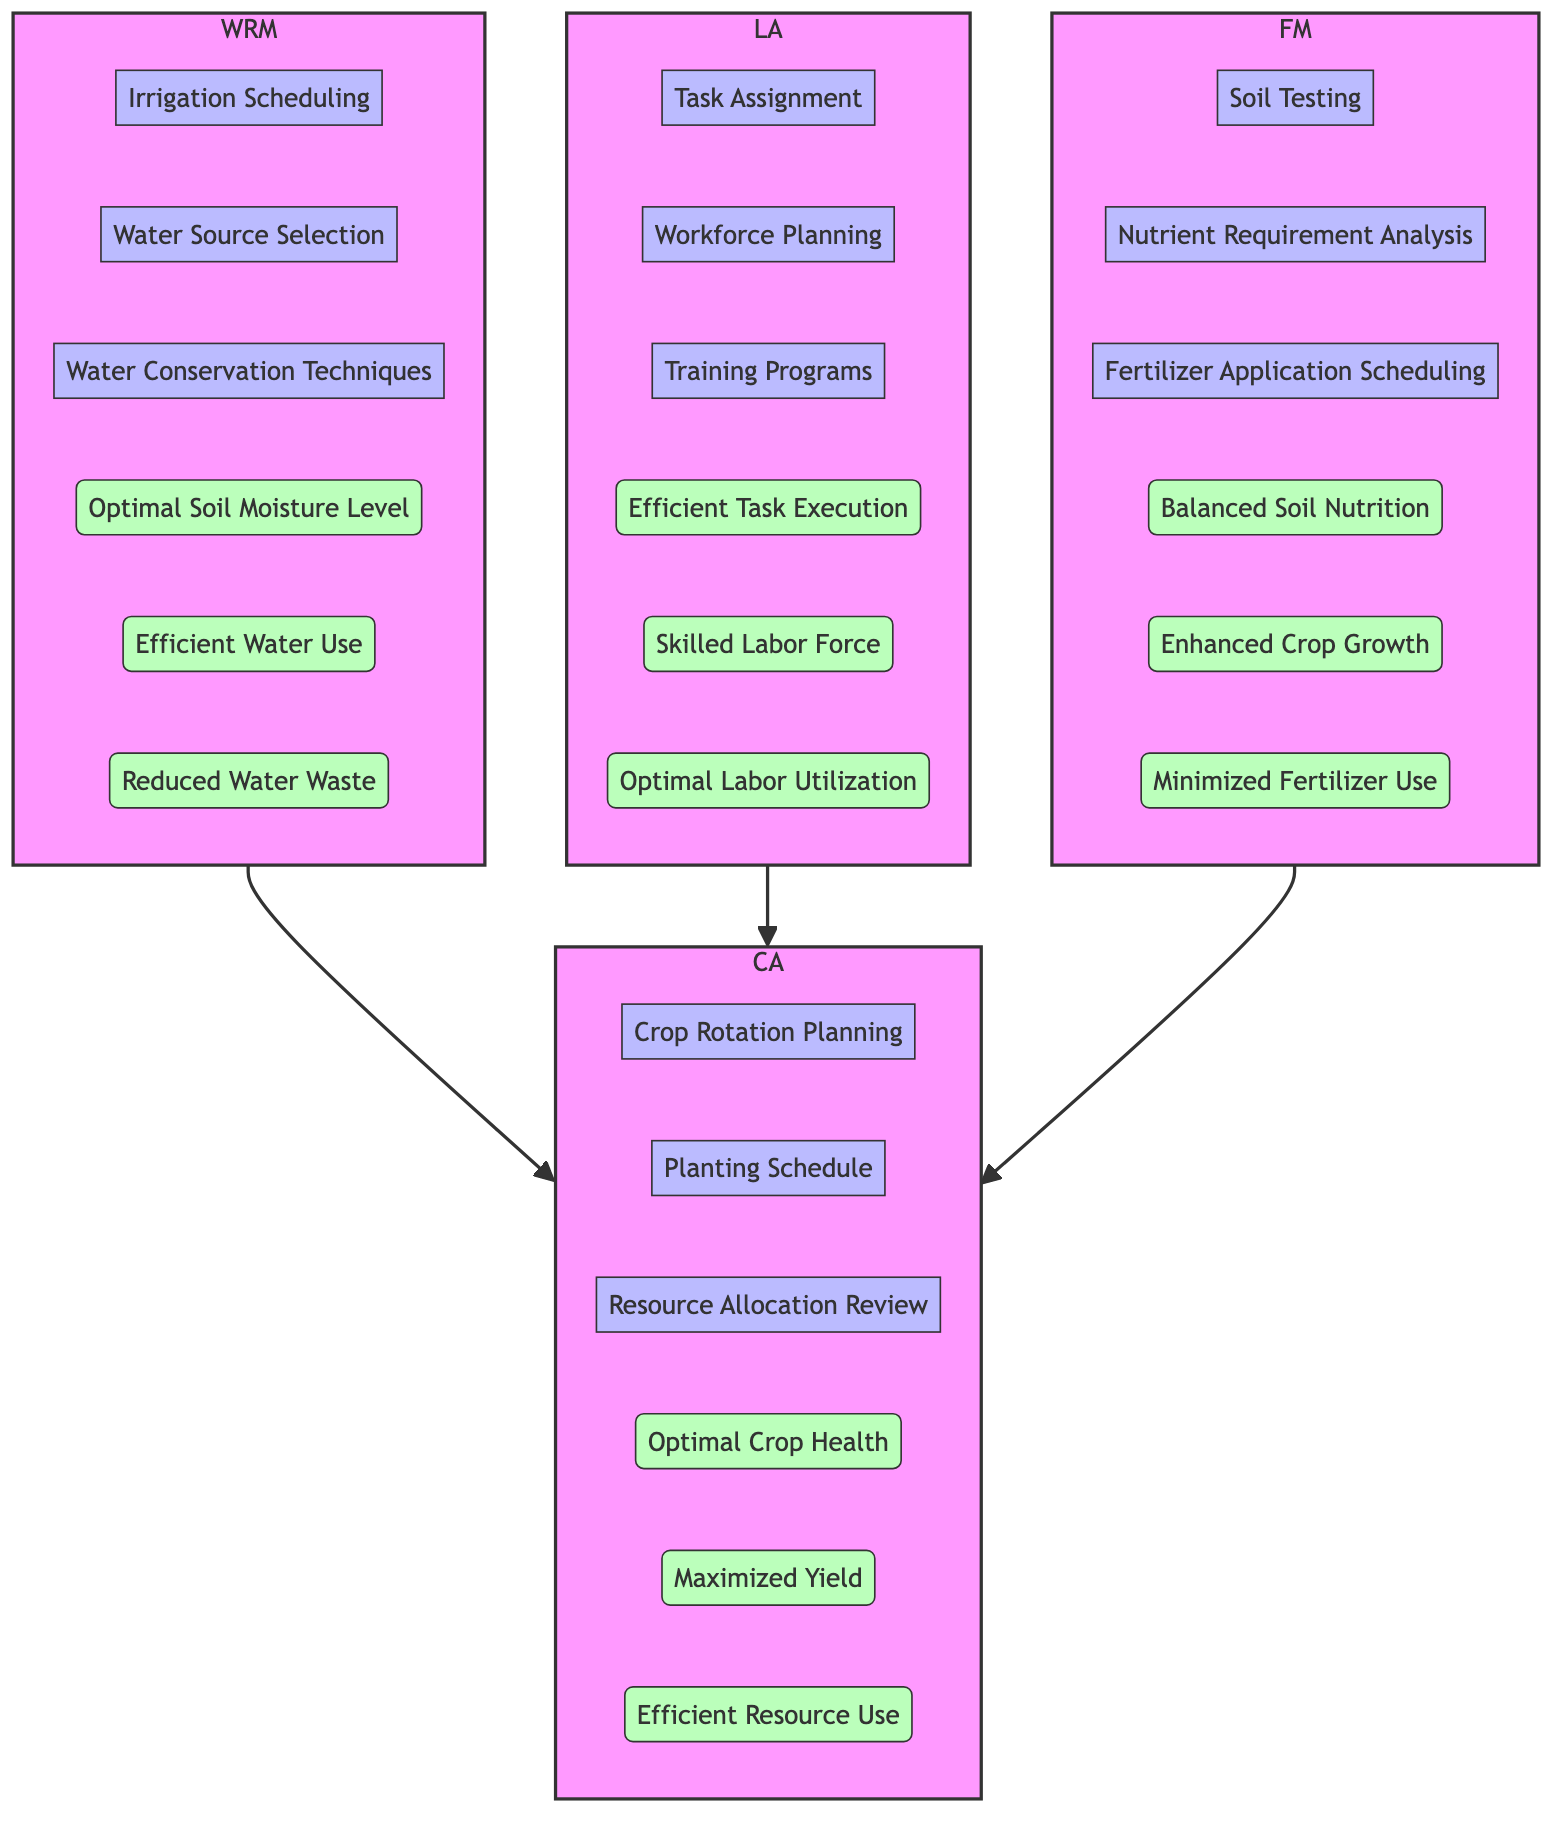What are the outputs of the Water Resource Management block? The outputs listed under the Water Resource Management block are "Optimal Soil Moisture Level," "Efficient Water Use," and "Reduced Water Waste." These outputs are shown as result processes of the inputs and processes within that block.
Answer: Optimal Soil Moisture Level, Efficient Water Use, Reduced Water Waste How many processes are involved in Labor Allocation? The Labor Allocation block contains three processes: "Task Assignment," "Workforce Planning," and "Training Programs." These processes are part of the internal workings of this block.
Answer: 3 Which block provides inputs to the Crop Allocation block? The Crop Allocation block receives inputs from three blocks: "Water Resource Management," "Labor Allocation," and "Fertilizer Management," indicated by arrows pointing into Crop Allocation from these three blocks.
Answer: Water Resource Management, Labor Allocation, Fertilizer Management What output is directly influenced by Fertilizer Management? The Fertilizer Management block outputs "Balanced Soil Nutrition," "Enhanced Crop Growth," and "Minimized Fertilizer Use," and all of these outputs influence crop yield and health. These outputs are results of analyzing soil and nutrient needs in combination with fertilizer application scheduling.
Answer: Balanced Soil Nutrition, Enhanced Crop Growth, Minimized Fertilizer Use Which process is common across all three blocks leading to Crop Allocation? The process of "Resource Allocation Review" is executed within the Crop Allocation block but relies on the inputs from the other three blocks for its successful execution. It ensures that resource management from water, labor, and fertilizer is aligned for optimal crop health.
Answer: Resource Allocation Review What is the ultimate goal of the Crop Allocation block? The objectives of the Crop Allocation block include achieving "Optimal Crop Health," maximizing crop yield, and ensuring resource use is efficient, all vital for effective crop management.
Answer: Optimal Crop Health, Maximized Yield, Efficient Resource Use 